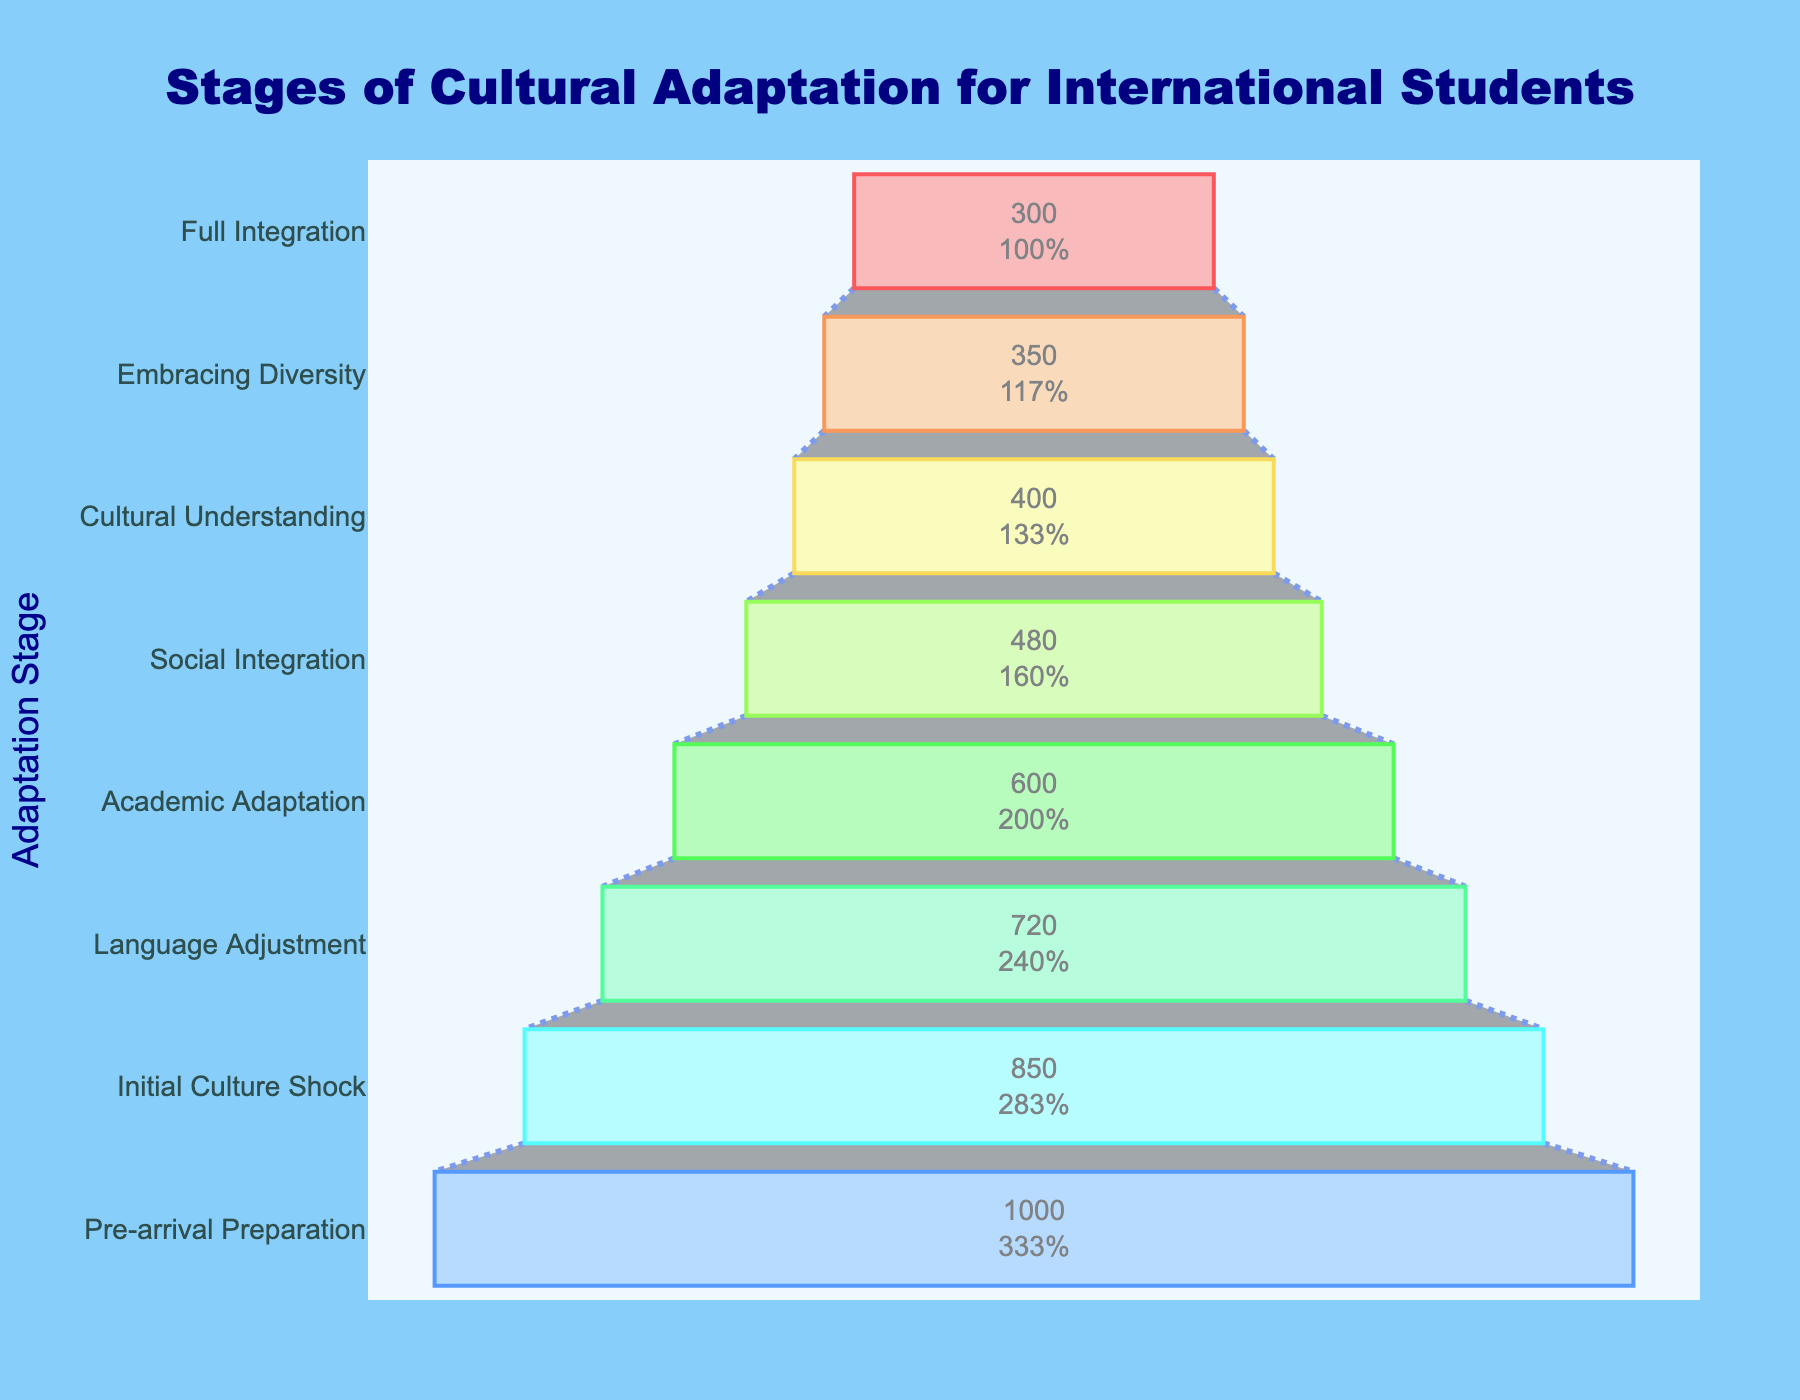What's the title of the figure? The title is usually located at the top of the figure. In this case, it is centered and reads "Stages of Cultural Adaptation for International Students."
Answer: Stages of Cultural Adaptation for International Students What are the stages of cultural adaptation shown in the figure? The stages are listed from top to bottom in the funnel chart. They are: Pre-arrival Preparation, Initial Culture Shock, Language Adjustment, Academic Adaptation, Social Integration, Cultural Understanding, Embracing Diversity, Full Integration.
Answer: Pre-arrival Preparation, Initial Culture Shock, Language Adjustment, Academic Adaptation, Social Integration, Cultural Understanding, Embracing Diversity, Full Integration Which stage has the highest number of students? The largest segment in the funnel chart typically indicates the stage with the highest number of students. This is the "Pre-arrival Preparation" stage with 1000 students.
Answer: Pre-arrival Preparation How many students are in the "Social Integration" stage? Locate the segment labeled "Social Integration" and read the associated number, which is 480 students.
Answer: 480 Compare the number of students in the "Language Adjustment" stage to the "Academic Adaptation" stage. The "Language Adjustment" stage has 720 students, and the "Academic Adaptation" stage has 600 students.
Answer: 720 vs 600 What percentage of the initial 1000 students reach the "Full Integration" stage? The "Full Integration" stage has 300 students. Divide 300 by the initial 1000 students and multiply by 100 to convert to a percentage. (300 / 1000) * 100 = 30%
Answer: 30% What is the difference in the number of students between the "Embracing Diversity" and "Cultural Understanding" stages? Subtract the number of students in the "Embracing Diversity" stage (350) from the number in the "Cultural Understanding" stage (400). 400 - 350 = 50
Answer: 50 What is the average number of students across all stages? Add the number of students across all stages (1000 + 850 + 720 + 600 + 480 + 400 + 350 + 300) = 4700, then divide by the number of stages (8). 4700 / 8 = 587.5
Answer: 587.5 Which two stages have the smallest difference in the number of students? Calculate the differences between all consecutive stages. The smallest difference is between "Cultural Understanding" (400) and "Embracing Diversity" (350), which is 50.
Answer: Cultural Understanding and Embracing Diversity By how much did the number of students decrease from the "Initial Culture Shock" to the "Language Adjustment" stage? Subtract the number of students in the "Language Adjustment" stage (720) from the number in the "Initial Culture Shock" stage (850). 850 - 720 = 130
Answer: 130 